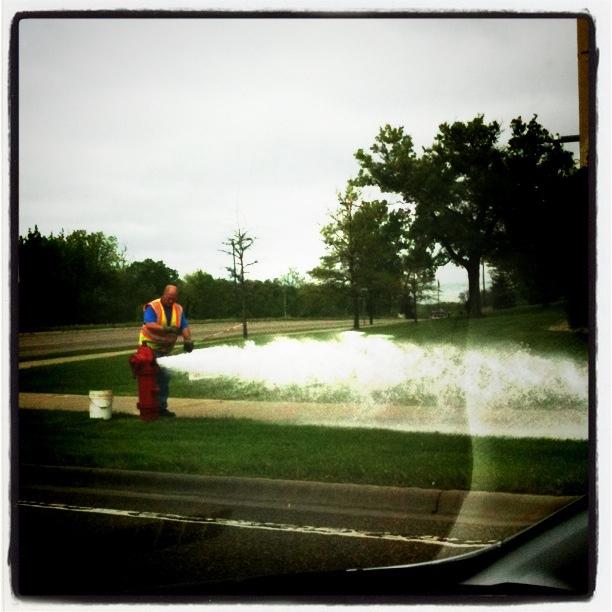What is the man doing?
Be succinct. Opening fire hydrant. What is next to the hydrant?
Be succinct. Man. How many people are in the scene?
Write a very short answer. 1. What color is the fire hydrant?
Be succinct. Red. 